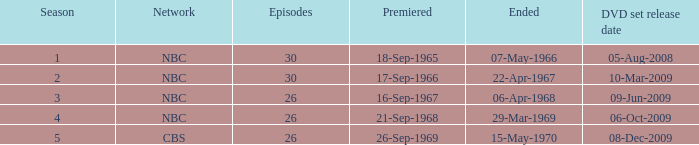For episodes after episode 30, what is the overall season count? None. 